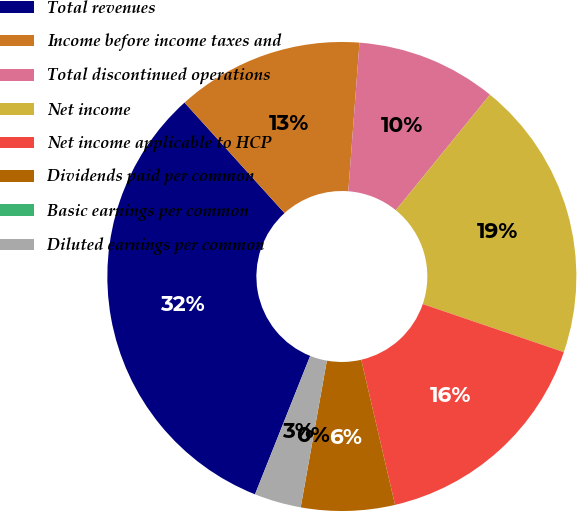Convert chart. <chart><loc_0><loc_0><loc_500><loc_500><pie_chart><fcel>Total revenues<fcel>Income before income taxes and<fcel>Total discontinued operations<fcel>Net income<fcel>Net income applicable to HCP<fcel>Dividends paid per common<fcel>Basic earnings per common<fcel>Diluted earnings per common<nl><fcel>32.26%<fcel>12.9%<fcel>9.68%<fcel>19.35%<fcel>16.13%<fcel>6.45%<fcel>0.0%<fcel>3.23%<nl></chart> 